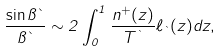Convert formula to latex. <formula><loc_0><loc_0><loc_500><loc_500>\frac { \sin \pi \theta } { \pi \theta } \sim 2 \int _ { 0 } ^ { 1 } \frac { n ^ { + } ( z ) } { T ^ { \theta } } \ell _ { \theta } ( z ) d z ,</formula> 